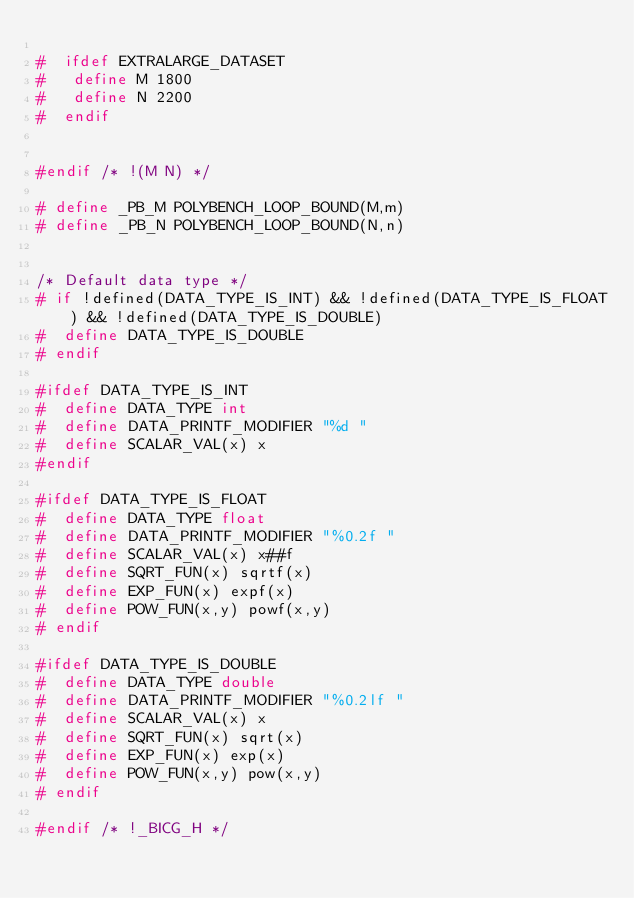Convert code to text. <code><loc_0><loc_0><loc_500><loc_500><_C_>
#  ifdef EXTRALARGE_DATASET
#   define M 1800
#   define N 2200
#  endif


#endif /* !(M N) */

# define _PB_M POLYBENCH_LOOP_BOUND(M,m)
# define _PB_N POLYBENCH_LOOP_BOUND(N,n)


/* Default data type */
# if !defined(DATA_TYPE_IS_INT) && !defined(DATA_TYPE_IS_FLOAT) && !defined(DATA_TYPE_IS_DOUBLE)
#  define DATA_TYPE_IS_DOUBLE
# endif

#ifdef DATA_TYPE_IS_INT
#  define DATA_TYPE int
#  define DATA_PRINTF_MODIFIER "%d "
#  define SCALAR_VAL(x) x
#endif

#ifdef DATA_TYPE_IS_FLOAT
#  define DATA_TYPE float
#  define DATA_PRINTF_MODIFIER "%0.2f "
#  define SCALAR_VAL(x) x##f
#  define SQRT_FUN(x) sqrtf(x)
#  define EXP_FUN(x) expf(x)
#  define POW_FUN(x,y) powf(x,y)
# endif

#ifdef DATA_TYPE_IS_DOUBLE
#  define DATA_TYPE double
#  define DATA_PRINTF_MODIFIER "%0.2lf "
#  define SCALAR_VAL(x) x
#  define SQRT_FUN(x) sqrt(x)
#  define EXP_FUN(x) exp(x)
#  define POW_FUN(x,y) pow(x,y)
# endif

#endif /* !_BICG_H */
</code> 